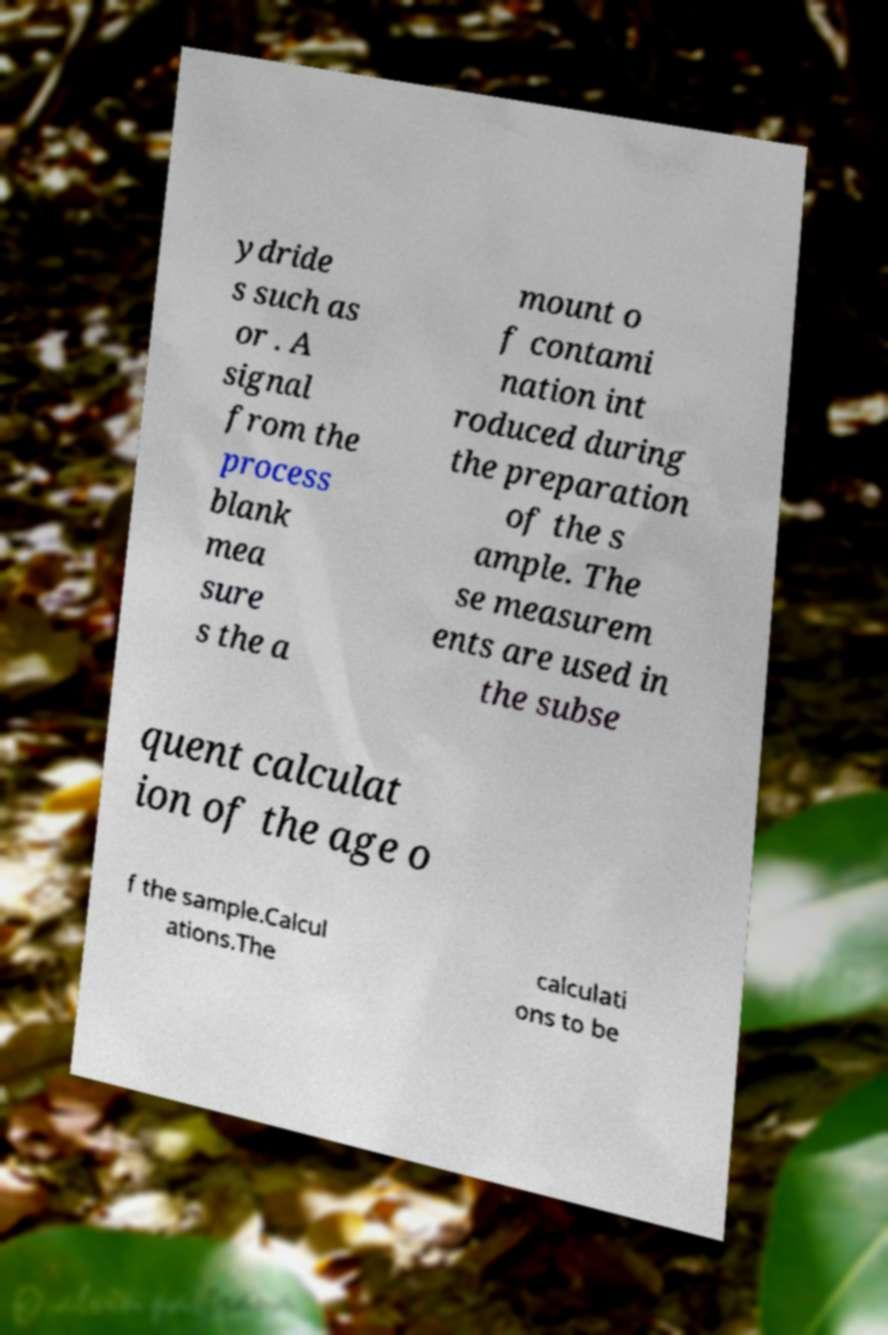There's text embedded in this image that I need extracted. Can you transcribe it verbatim? ydride s such as or . A signal from the process blank mea sure s the a mount o f contami nation int roduced during the preparation of the s ample. The se measurem ents are used in the subse quent calculat ion of the age o f the sample.Calcul ations.The calculati ons to be 